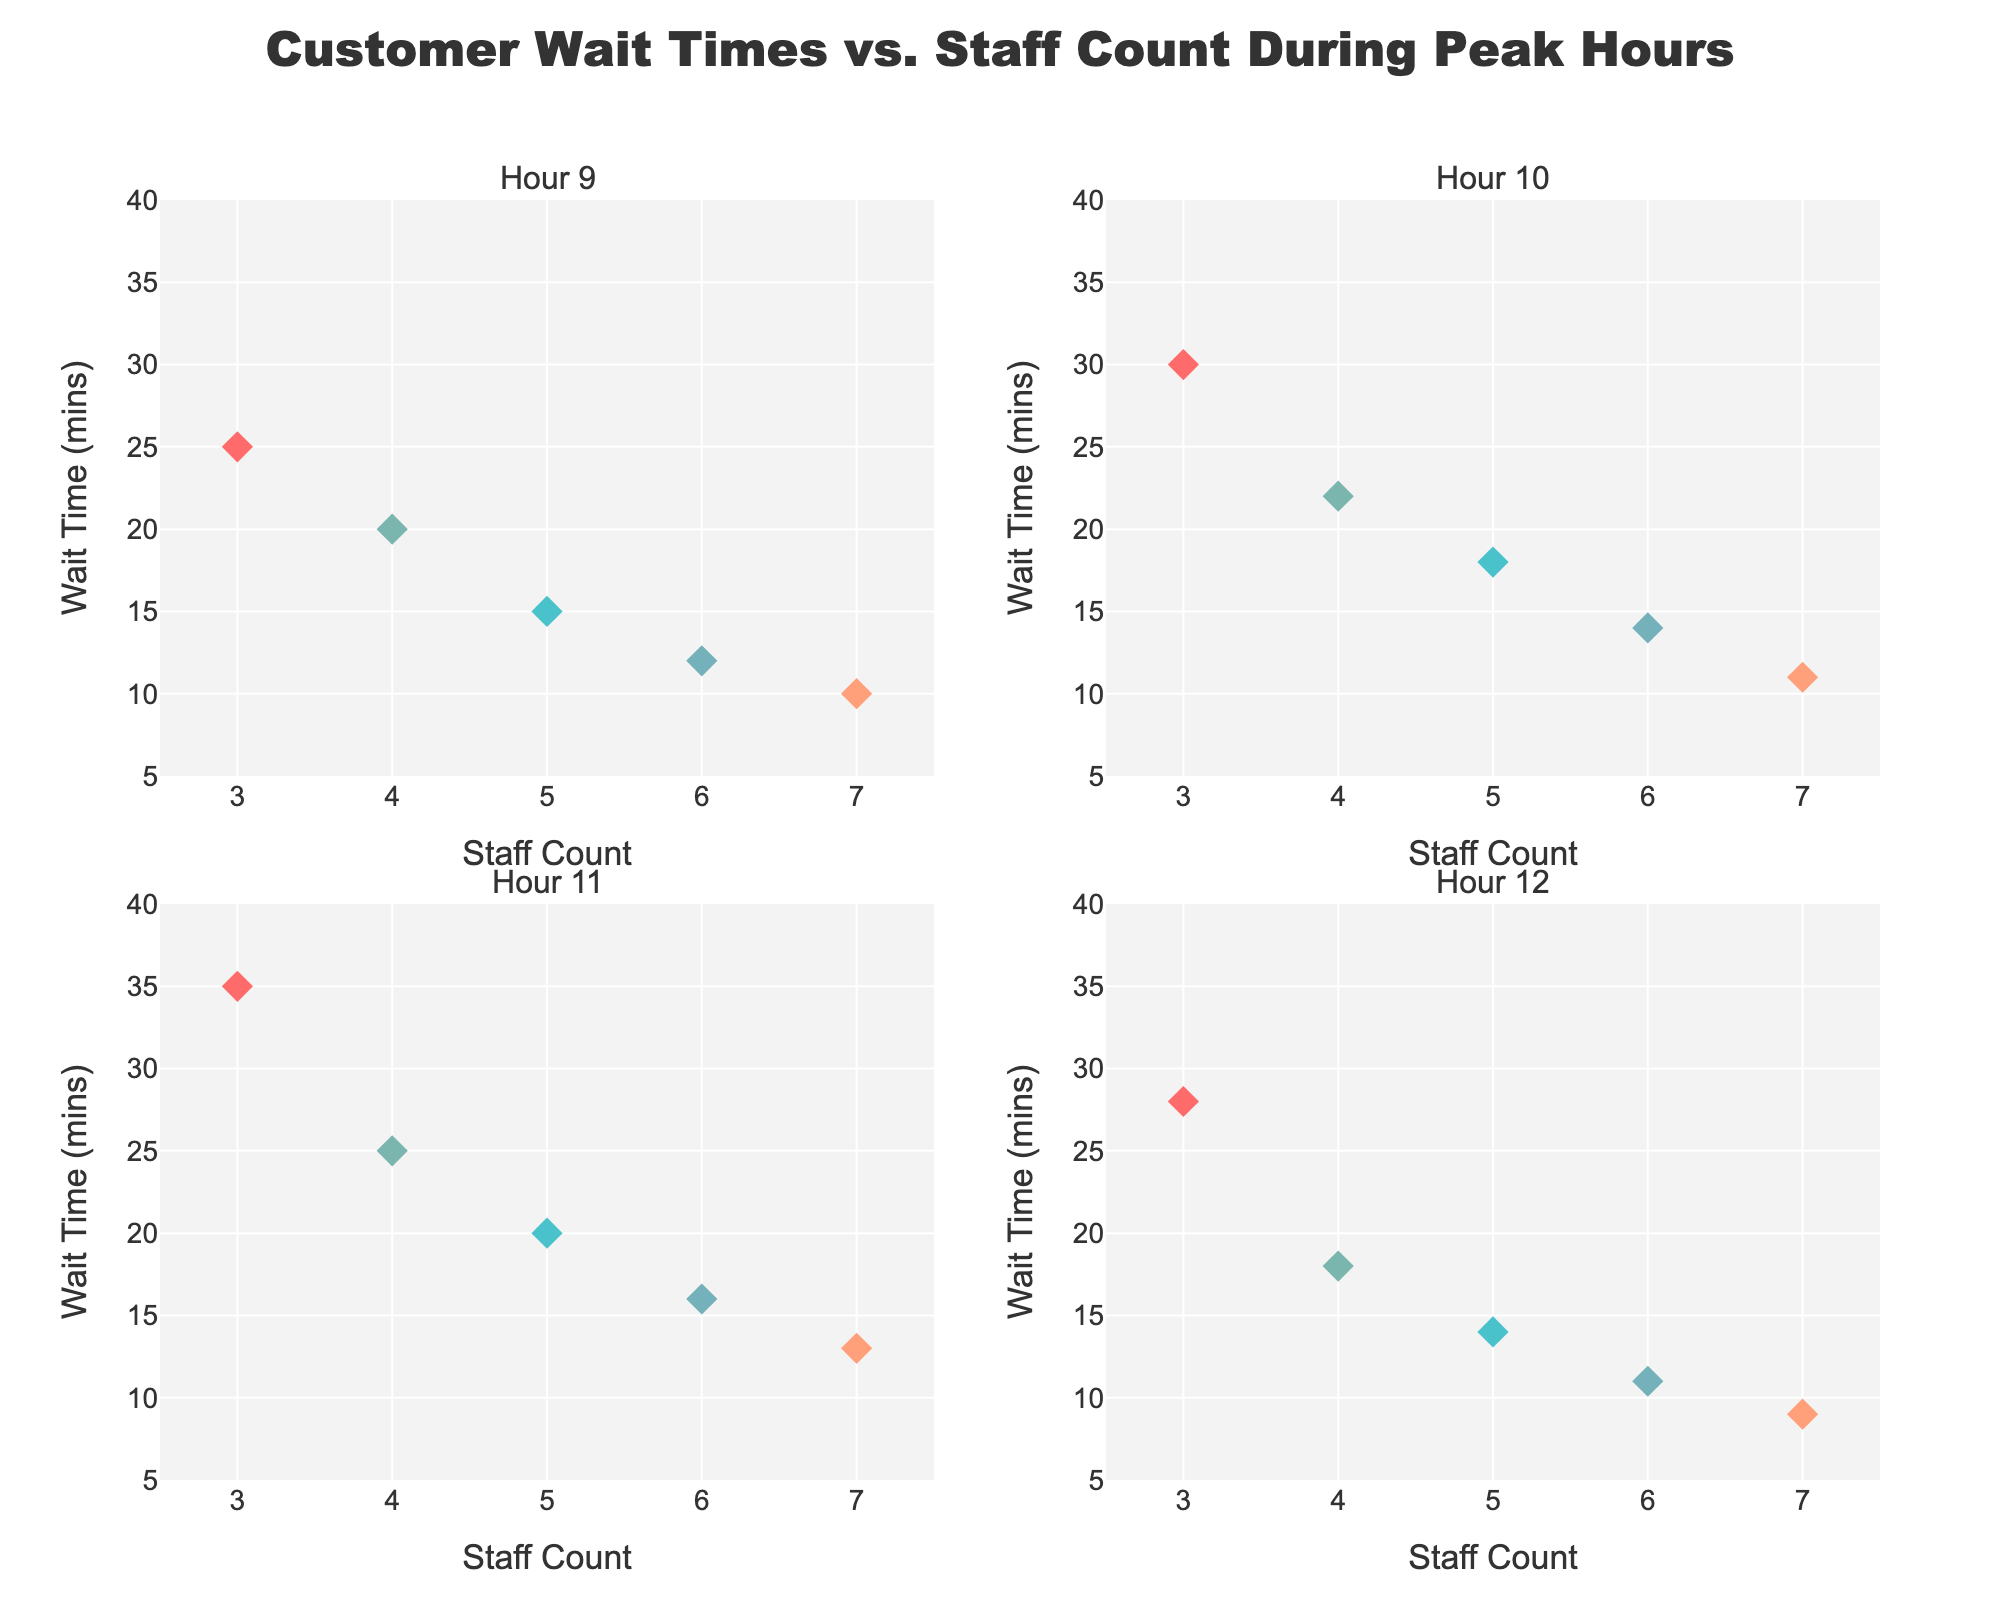What is the title of the figure? The title is usually located at the top of the figure, clearly summarizing what the graph is about. The title reads "Customer Wait Times vs. Staff Count During Peak Hours".
Answer: Customer Wait Times vs. Staff Count During Peak Hours How many hours are shown in the subplots? We look at the subplot titles or the labels which indicate the hours. There are four subplots, each representing a different hour.
Answer: 4 At what hour does having 7 staff members result in the lowest wait time, and what is this wait time? At each subplot corresponding to hours 9, 10, 11, and 12, we see that the marker for 7 staff members has different wait times. At hour 12, the wait time for 7 staff members is the lowest, at 9 minutes.
Answer: 12, 9 minutes What's the shortest wait time recorded at hour 11? By examining the subplot for hour 11, we find the smallest y-value, which represents the wait time. The shortest wait time is 13 minutes at hour 11, found on the marker hovering-over information.
Answer: 13 minutes Is there a correlation between the number of staff and wait times across all hours? We observe that as the number of staff increases from 3 to 7, the wait times generally decrease across all subplots. This suggests a negative correlation between staff count and wait times.
Answer: Yes What is the average wait time for hours 9 and 10 with 4 staff members? First, we check the specific wait times for 4 staff members at hours 9 (20 mins) and 10 (22 mins). The average is calculated as (20 + 22)/2.
Answer: 21 minutes Which hour shows the greatest variation in wait times? We compare the range of wait times across the four subplots. The hour with the widest range between the highest and lowest wait times will show the greatest variation. Hour 11 ranges from 13 to 35 minutes, showing the greatest variation.
Answer: Hour 11 Which hour has the most consistent wait times regardless of staff count? Consistency is indicated by the smallest range of wait times. Checking across hours 9, 10, 11, and 12, hours 9 and 12 both have relatively small ranges, but hour 12 is slightly narrower at 9 to 28 minutes (19 minutes range), whereas hour 9 ranges from 10 to 25 minutes (15 minutes range).
Answer: Hour 9 What is the hover info shown for the marker with the highest wait time at hour 10? By checking the marker with the highest y-value in the hour 10 subplot, we notice the hover info shows "35 mins".
Answer: 35 mins 